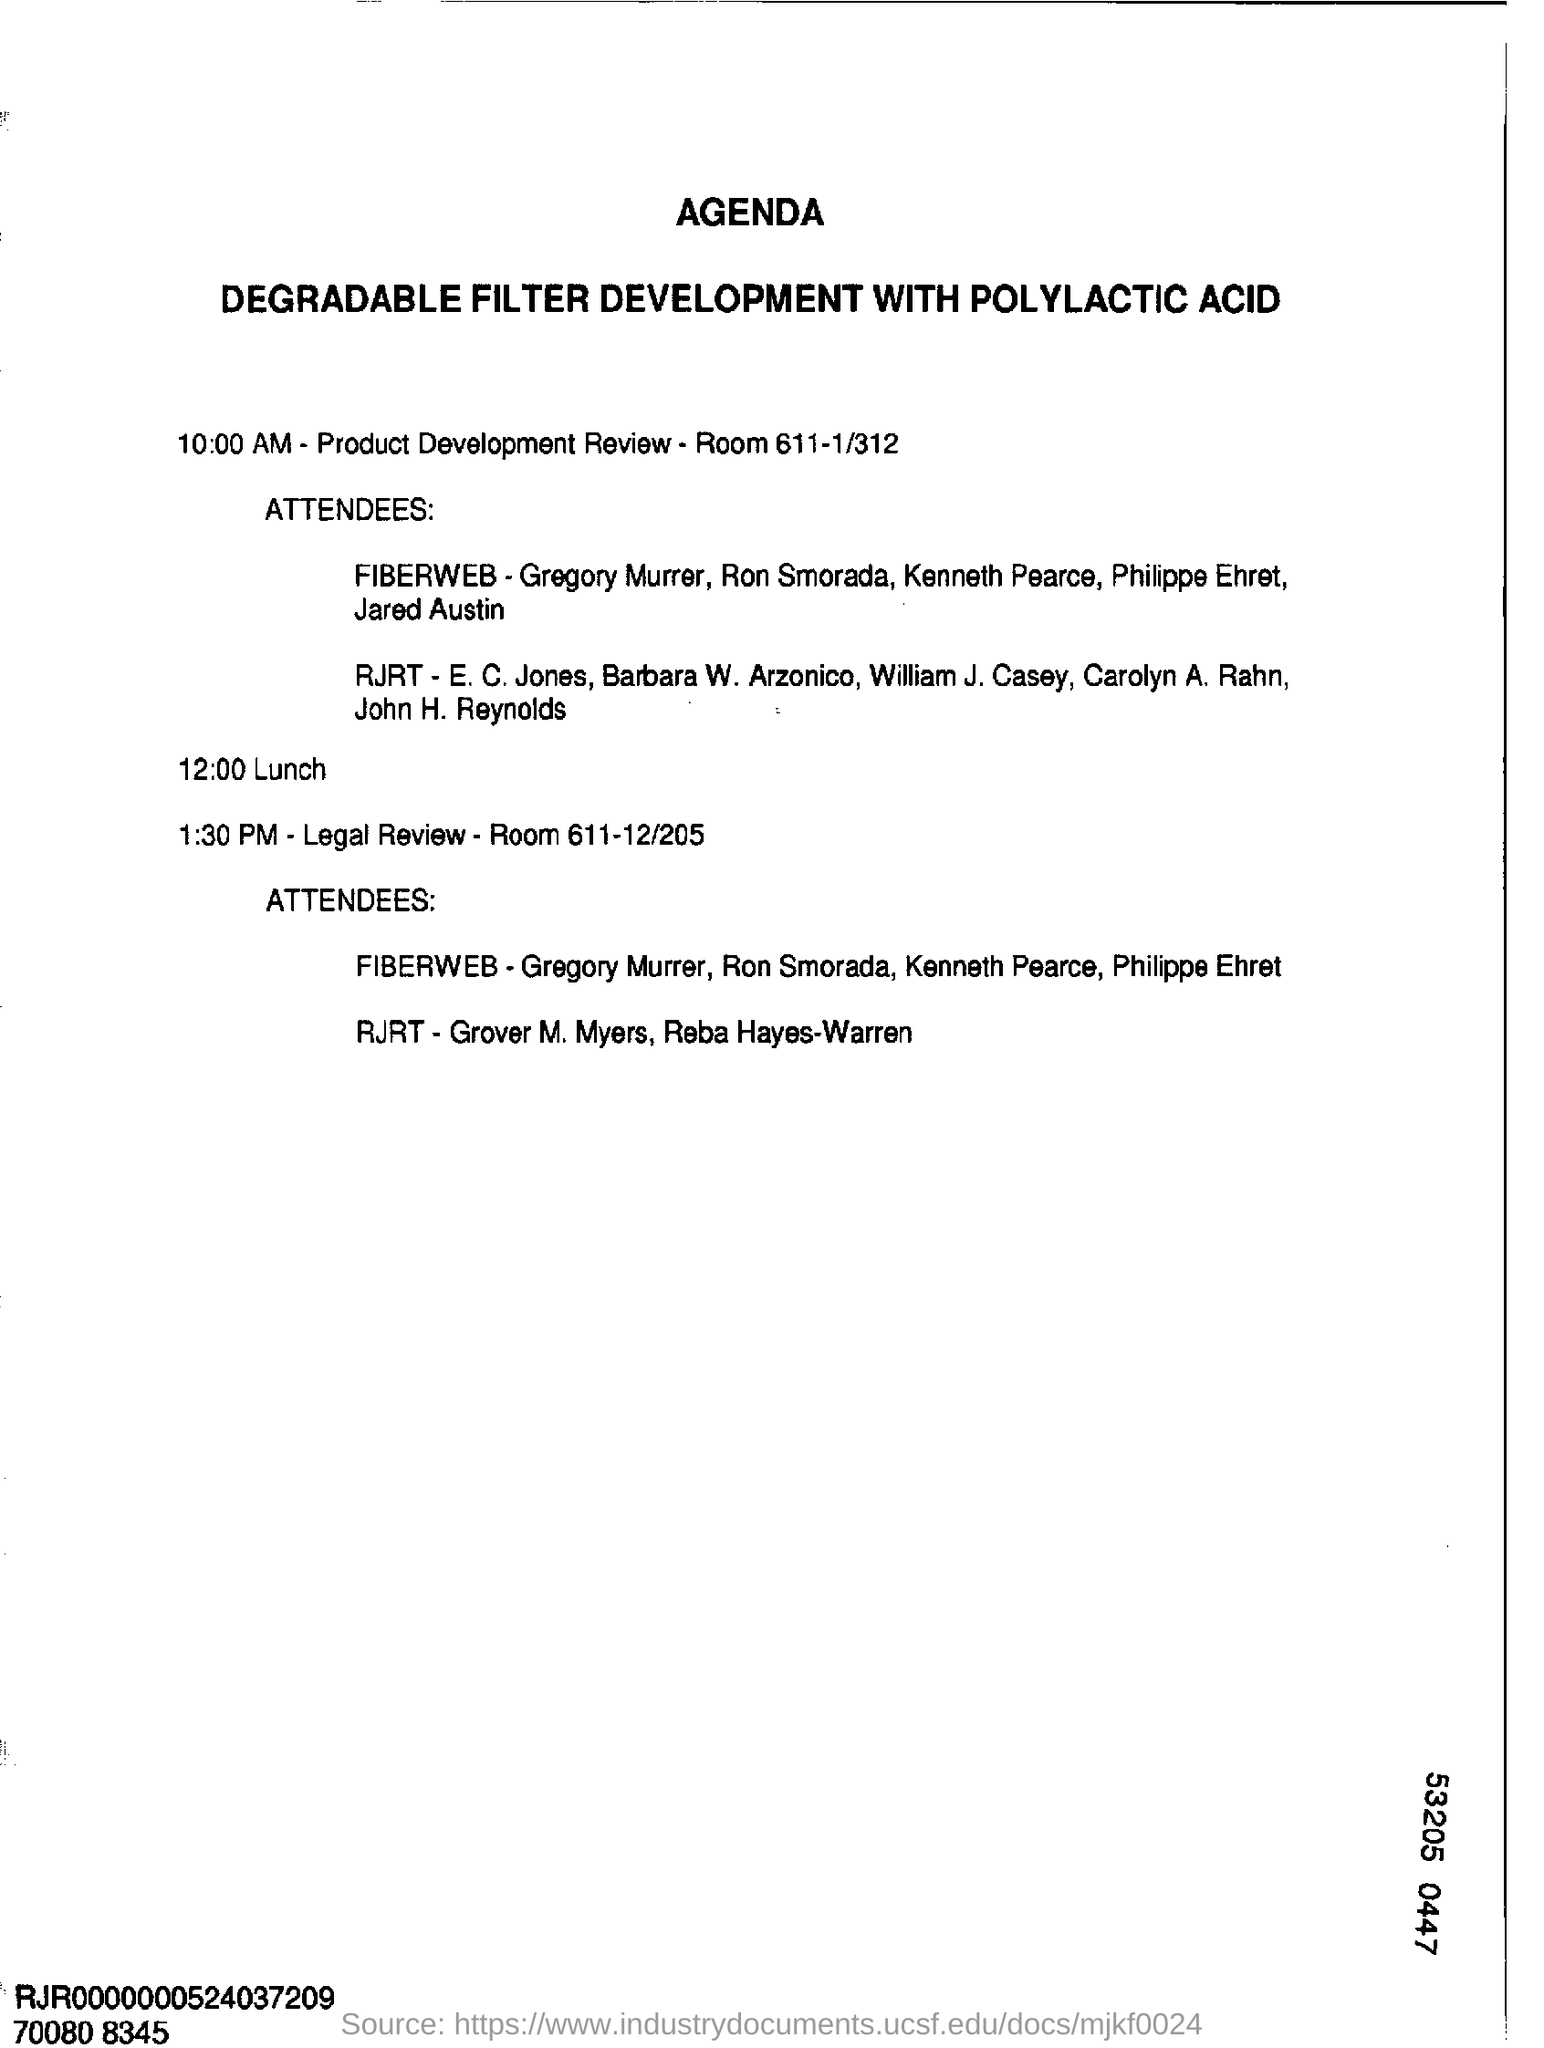Mention a couple of crucial points in this snapshot. At 1.30 PM, a program on legal review will be taking place. The document outlines a plan for the development of a degradable filter using Polylactic Acid as the primary component. The product development review is scheduled to take place in Room 611-1/312. 